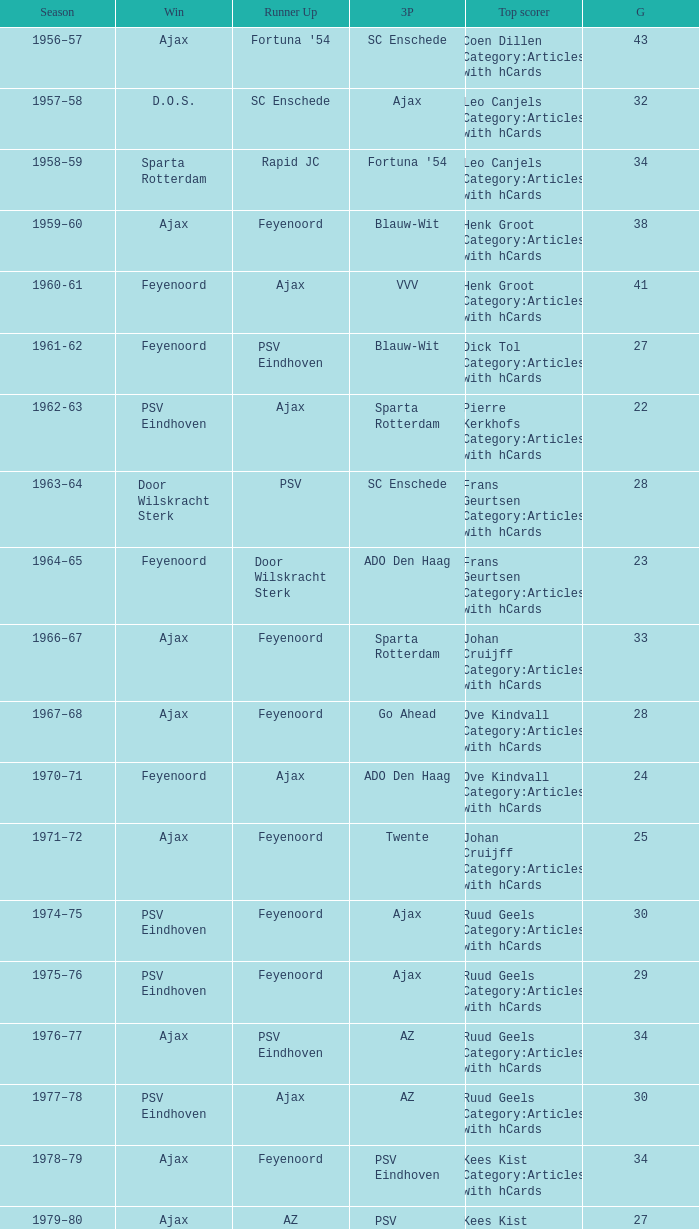When twente came in third place and ajax was the winner what are the seasons? 1971–72, 1989-90. 